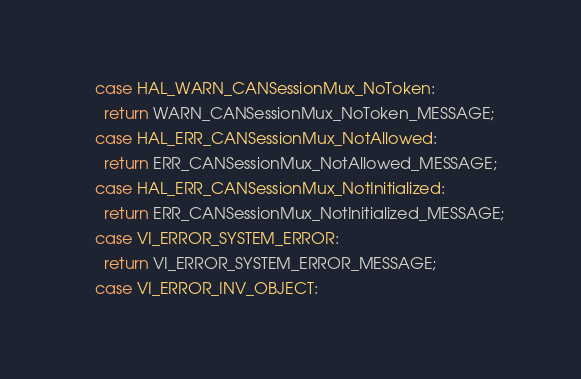<code> <loc_0><loc_0><loc_500><loc_500><_C++_>    case HAL_WARN_CANSessionMux_NoToken:
      return WARN_CANSessionMux_NoToken_MESSAGE;
    case HAL_ERR_CANSessionMux_NotAllowed:
      return ERR_CANSessionMux_NotAllowed_MESSAGE;
    case HAL_ERR_CANSessionMux_NotInitialized:
      return ERR_CANSessionMux_NotInitialized_MESSAGE;
    case VI_ERROR_SYSTEM_ERROR:
      return VI_ERROR_SYSTEM_ERROR_MESSAGE;
    case VI_ERROR_INV_OBJECT:</code> 